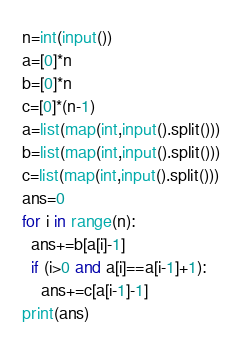Convert code to text. <code><loc_0><loc_0><loc_500><loc_500><_Python_>n=int(input())
a=[0]*n
b=[0]*n
c=[0]*(n-1)
a=list(map(int,input().split()))
b=list(map(int,input().split()))
c=list(map(int,input().split()))
ans=0
for i in range(n):
  ans+=b[a[i]-1]
  if (i>0 and a[i]==a[i-1]+1):
    ans+=c[a[i-1]-1]
print(ans)</code> 